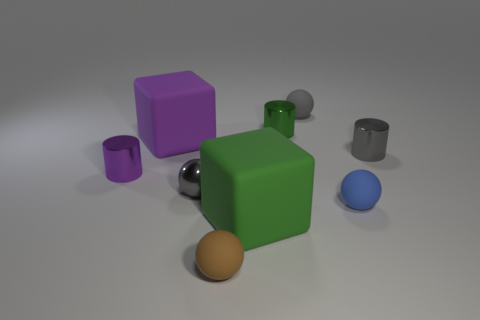Do the tiny matte thing that is in front of the green block and the small gray matte thing have the same shape?
Ensure brevity in your answer.  Yes. Are there any tiny metallic things of the same shape as the small blue rubber object?
Your answer should be compact. Yes. What is the material of the small cylinder that is the same color as the shiny sphere?
Keep it short and to the point. Metal. There is a small gray metallic object on the right side of the small matte sphere that is behind the gray metallic sphere; what is its shape?
Keep it short and to the point. Cylinder. What number of tiny gray cylinders have the same material as the green cylinder?
Make the answer very short. 1. There is a small sphere that is the same material as the green cylinder; what is its color?
Offer a terse response. Gray. There is a block to the left of the gray sphere that is on the left side of the big cube that is in front of the small purple cylinder; what is its size?
Ensure brevity in your answer.  Large. Is the number of tiny brown matte spheres less than the number of big rubber cubes?
Your response must be concise. Yes. There is another big thing that is the same shape as the large purple rubber object; what is its color?
Give a very brief answer. Green. Is there a gray matte ball in front of the small gray cylinder right of the gray metal thing on the left side of the brown object?
Offer a terse response. No. 